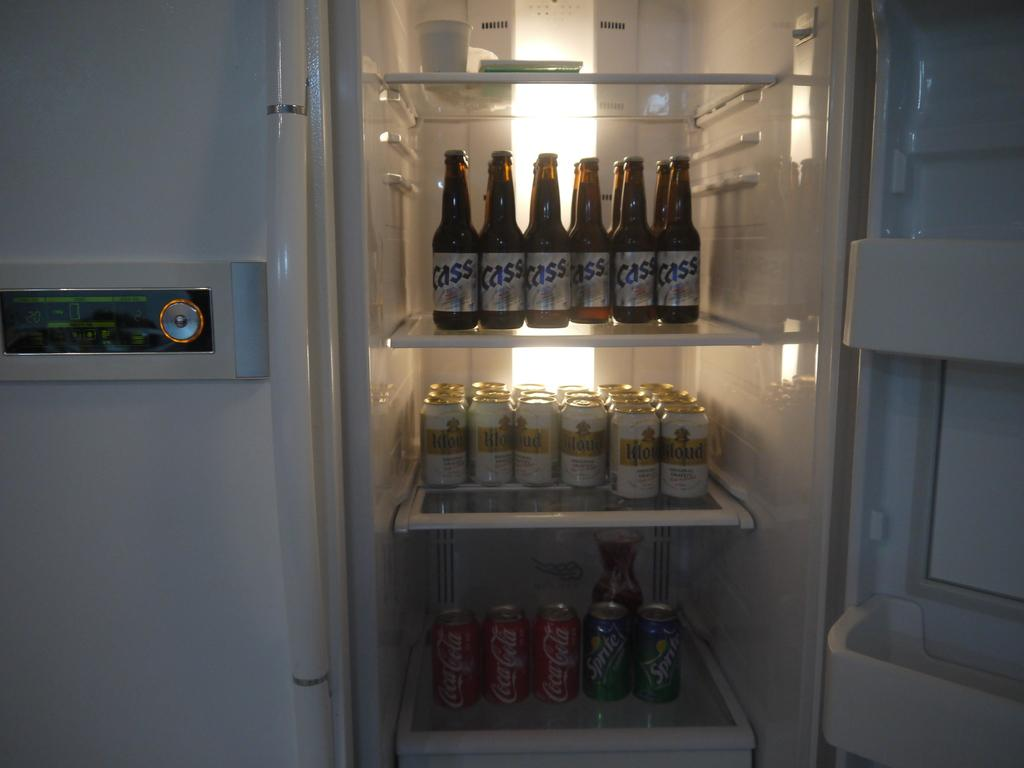What objects can be seen in the image? There are bottles in the image. Where are the bottles located? The bottles are inside a refrigerator. What type of leather is visible on the bottles in the image? There is no leather visible on the bottles in the image, as they are made of glass or plastic and contain liquid. 